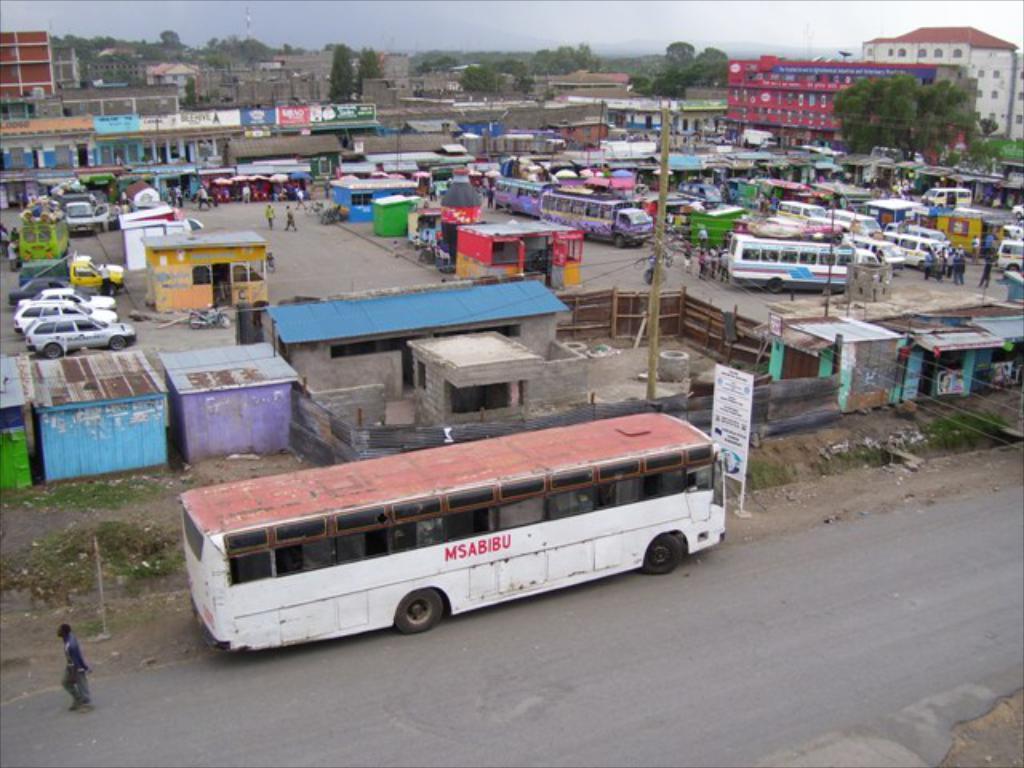In one or two sentences, can you explain what this image depicts? In this image we can see vehicles, small rooms and few persons on the ground. In the background there are buildings, trees, poles, hoardings and sky. 